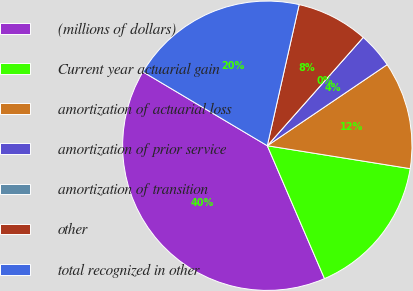<chart> <loc_0><loc_0><loc_500><loc_500><pie_chart><fcel>(millions of dollars)<fcel>Current year actuarial gain<fcel>amortization of actuarial loss<fcel>amortization of prior service<fcel>amortization of transition<fcel>other<fcel>total recognized in other<nl><fcel>40.0%<fcel>16.0%<fcel>12.0%<fcel>4.0%<fcel>0.0%<fcel>8.0%<fcel>20.0%<nl></chart> 